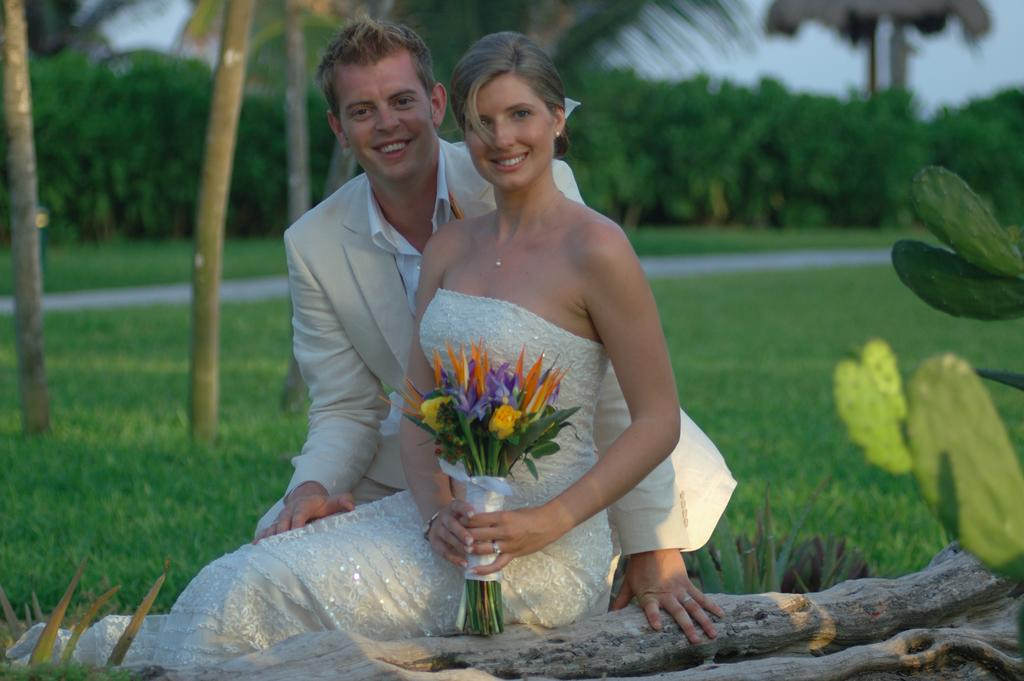How many people are present in the image? There is a man and a woman present in the image. What is the woman holding in the image? The woman is holding a bouquet. What can be seen in the background of the image? There are trees, sky, and grass visible in the background of the image. What is the condition of the background in the image? The background of the image is blurry. What type of wood is the man attacking in the image? There is no man attacking any wood in the image. What is the reason for the war depicted in the image? There is no war depicted in the image. 